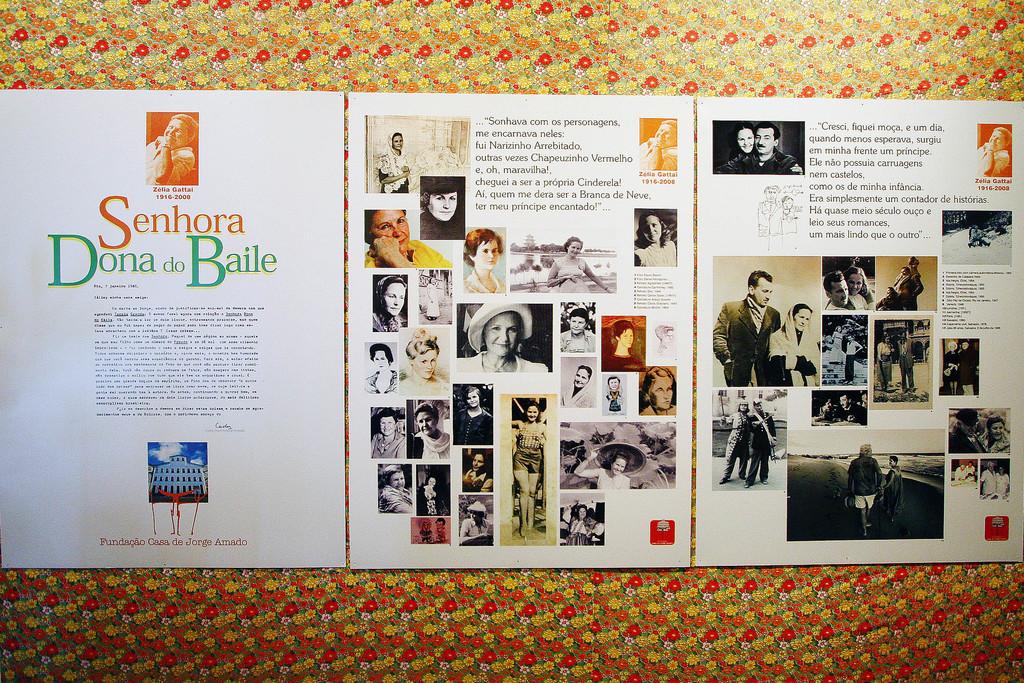What is the name of the book?
Ensure brevity in your answer.  Senhora dona do baile. 